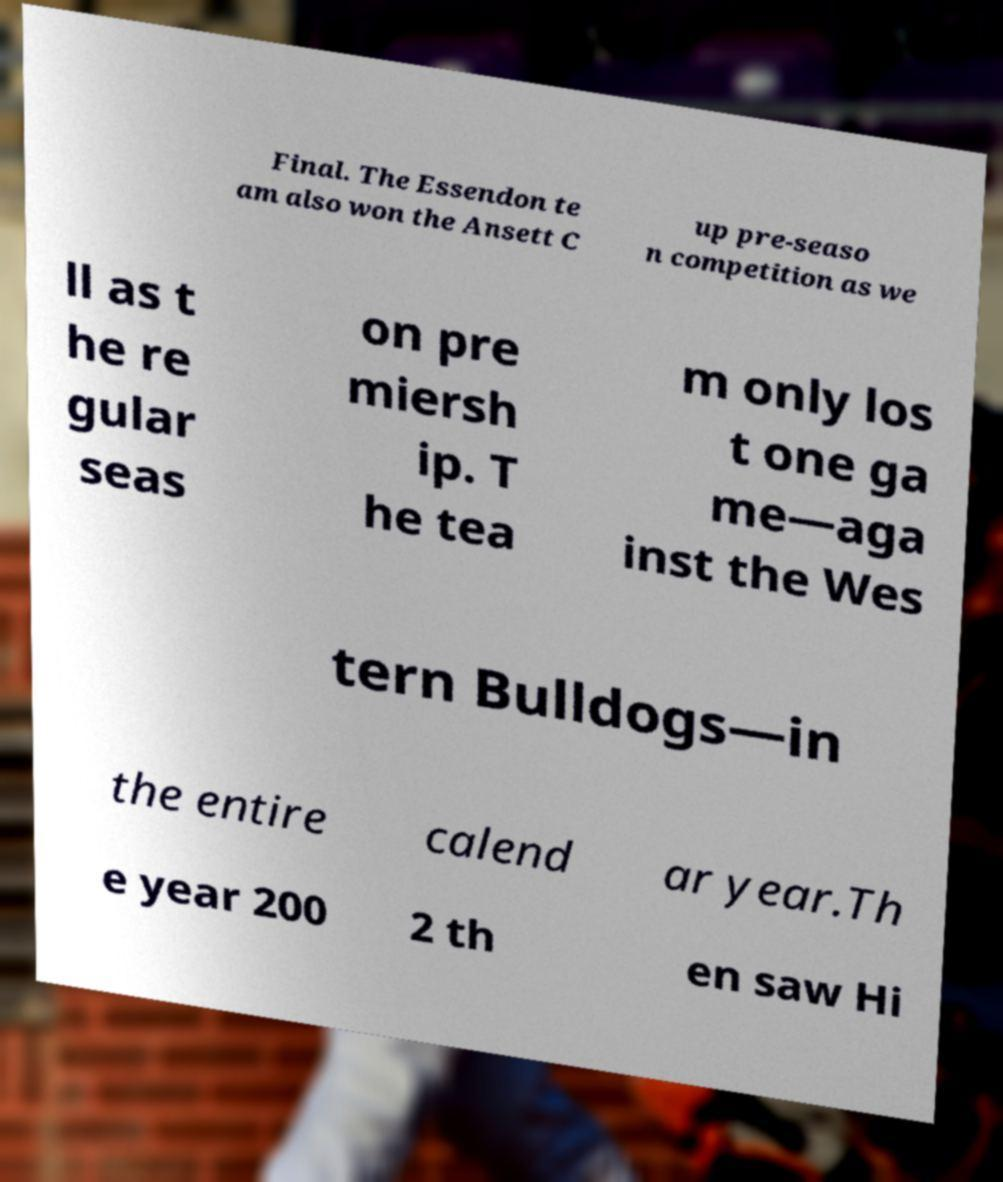Please read and relay the text visible in this image. What does it say? Final. The Essendon te am also won the Ansett C up pre-seaso n competition as we ll as t he re gular seas on pre miersh ip. T he tea m only los t one ga me—aga inst the Wes tern Bulldogs—in the entire calend ar year.Th e year 200 2 th en saw Hi 